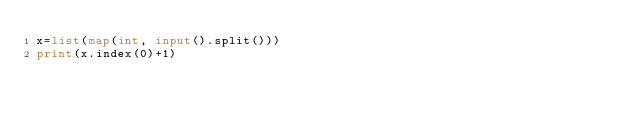<code> <loc_0><loc_0><loc_500><loc_500><_Python_>x=list(map(int, input().split()))
print(x.index(0)+1)</code> 